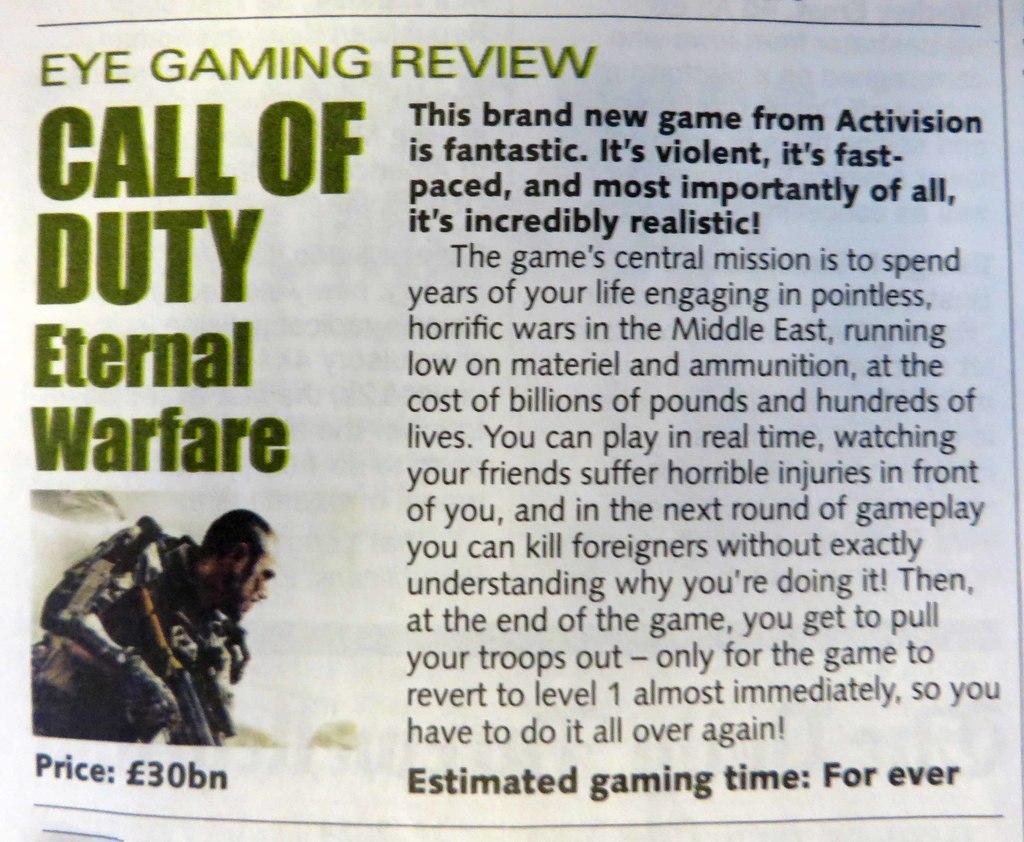<image>
Present a compact description of the photo's key features. An article that is by eye gaming review of coll of duty eternal warefare. 